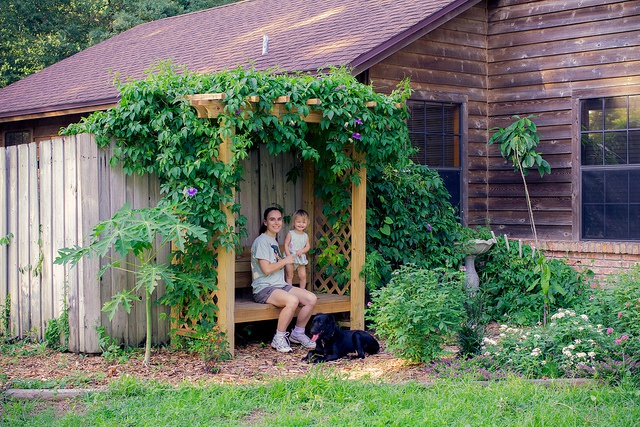Describe the objects in this image and their specific colors. I can see people in darkgreen, darkgray, lightpink, brown, and gray tones, dog in darkgreen, black, navy, gray, and brown tones, bench in darkgreen, gray, tan, and black tones, and people in darkgreen, gray, darkgray, and lightpink tones in this image. 